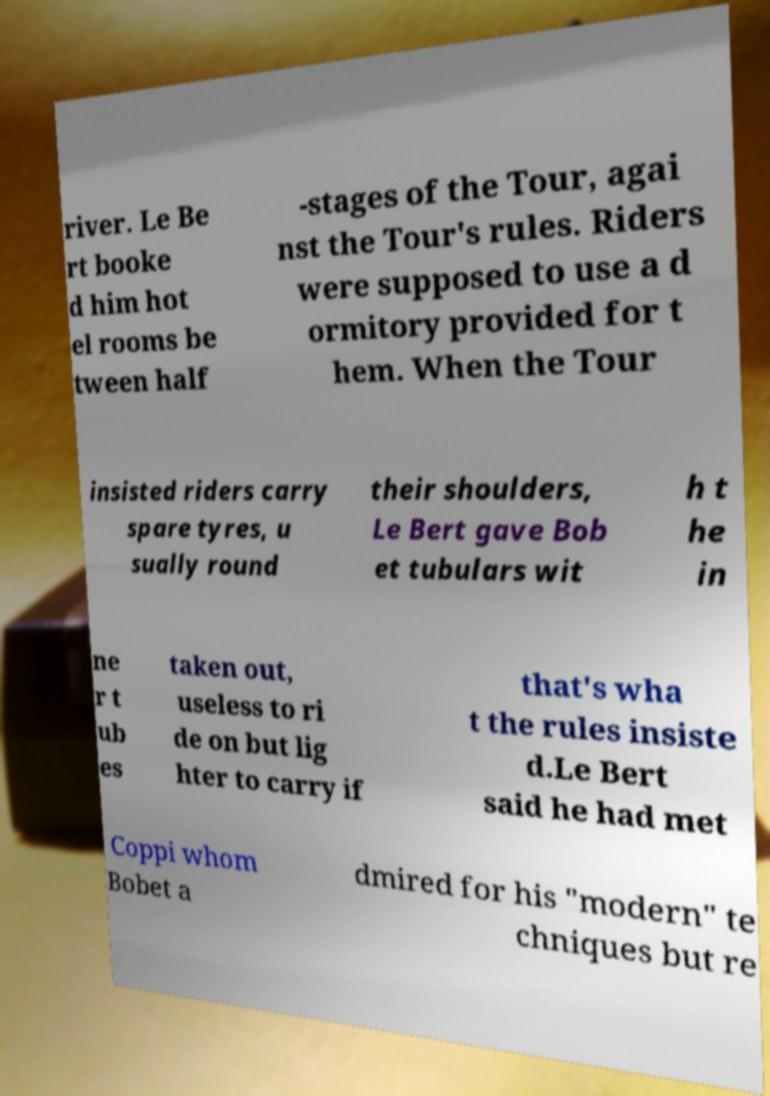There's text embedded in this image that I need extracted. Can you transcribe it verbatim? river. Le Be rt booke d him hot el rooms be tween half -stages of the Tour, agai nst the Tour's rules. Riders were supposed to use a d ormitory provided for t hem. When the Tour insisted riders carry spare tyres, u sually round their shoulders, Le Bert gave Bob et tubulars wit h t he in ne r t ub es taken out, useless to ri de on but lig hter to carry if that's wha t the rules insiste d.Le Bert said he had met Coppi whom Bobet a dmired for his "modern" te chniques but re 